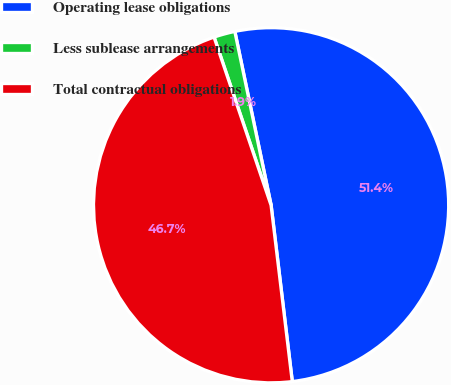Convert chart to OTSL. <chart><loc_0><loc_0><loc_500><loc_500><pie_chart><fcel>Operating lease obligations<fcel>Less sublease arrangements<fcel>Total contractual obligations<nl><fcel>51.37%<fcel>1.93%<fcel>46.7%<nl></chart> 